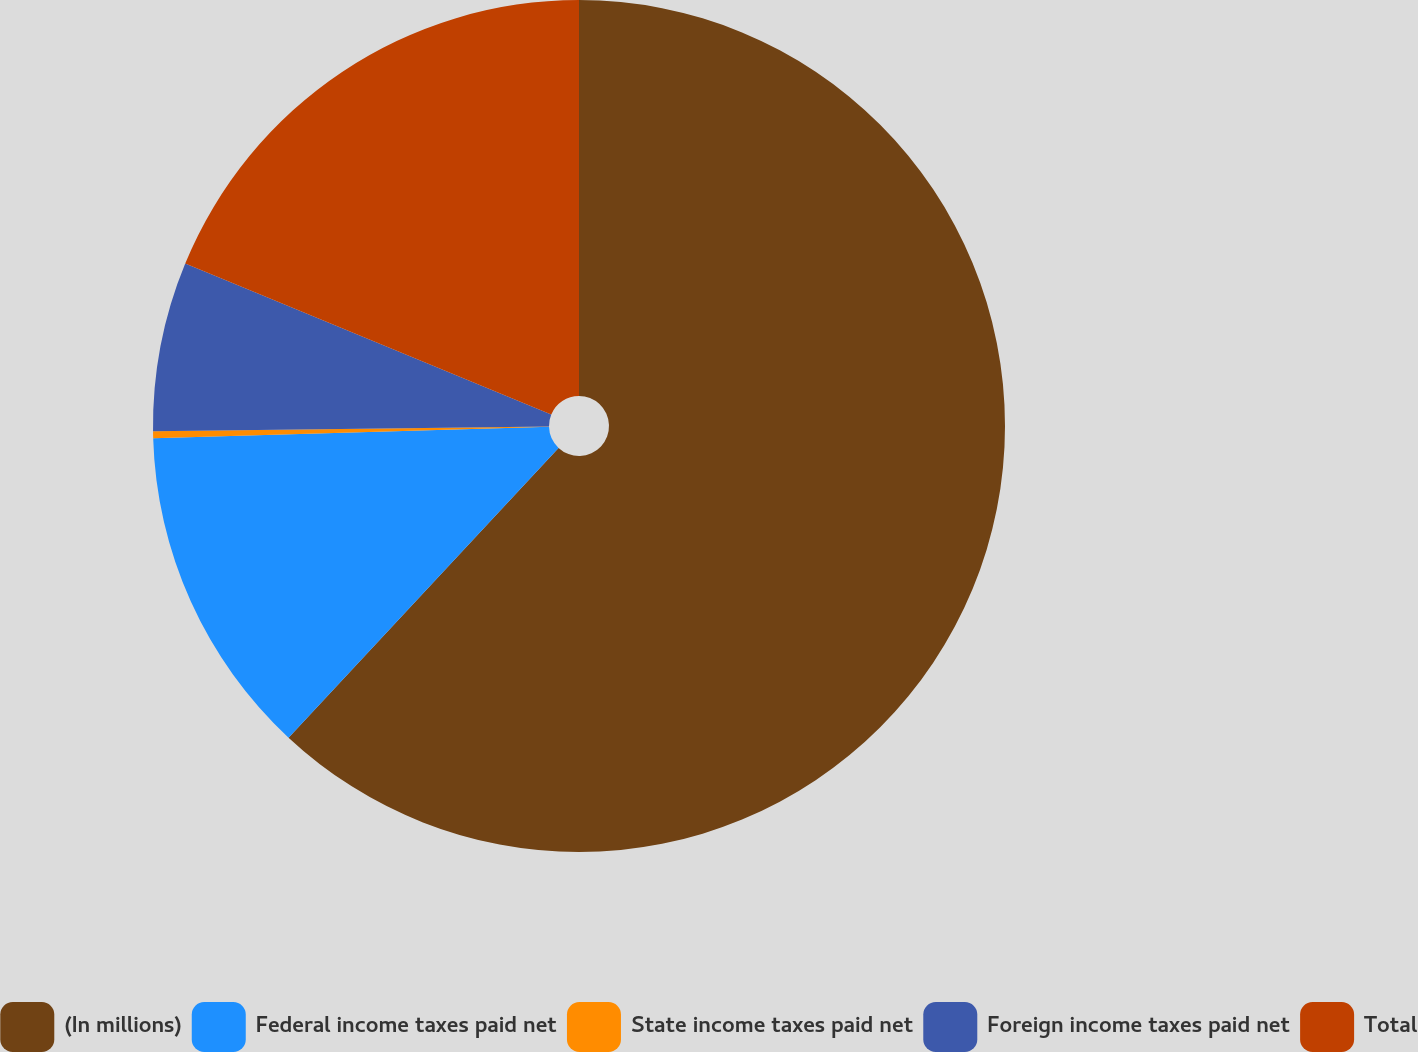Convert chart. <chart><loc_0><loc_0><loc_500><loc_500><pie_chart><fcel>(In millions)<fcel>Federal income taxes paid net<fcel>State income taxes paid net<fcel>Foreign income taxes paid net<fcel>Total<nl><fcel>61.94%<fcel>12.6%<fcel>0.26%<fcel>6.43%<fcel>18.77%<nl></chart> 